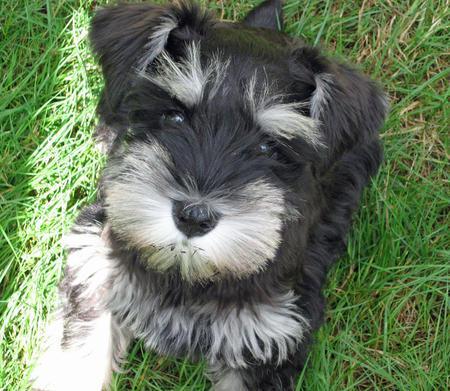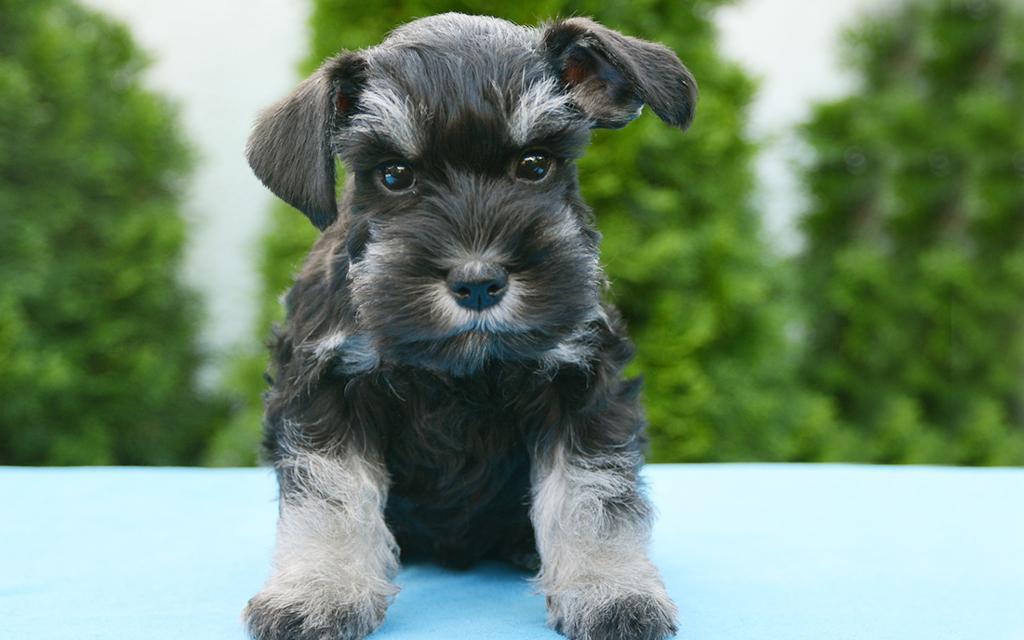The first image is the image on the left, the second image is the image on the right. For the images displayed, is the sentence "The dogs in both images are looking forward." factually correct? Answer yes or no. Yes. 